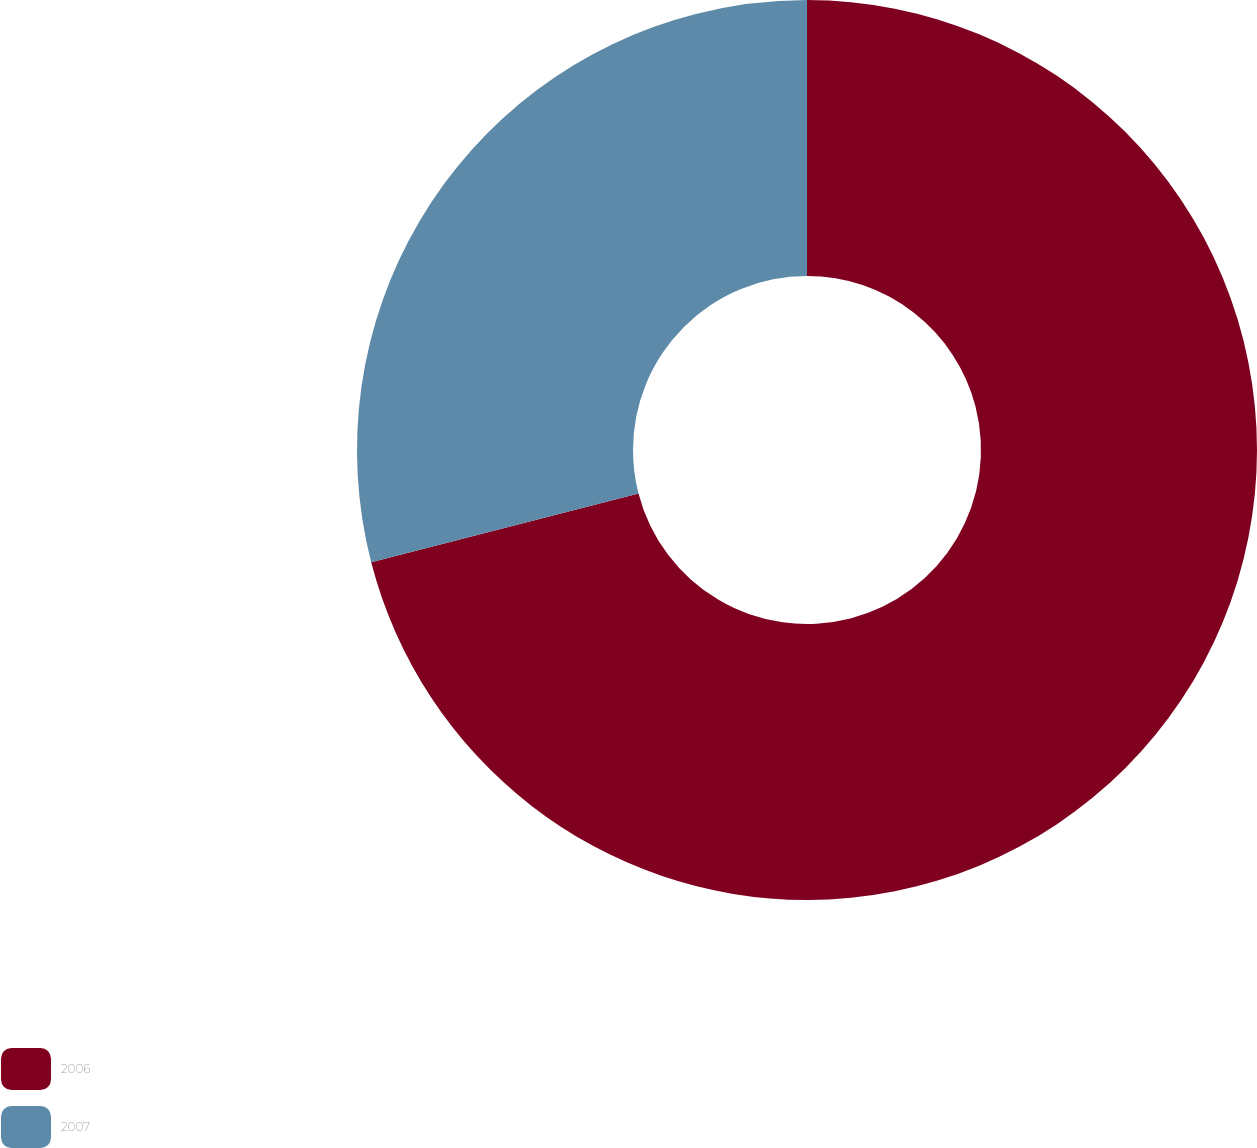Convert chart to OTSL. <chart><loc_0><loc_0><loc_500><loc_500><pie_chart><fcel>2006<fcel>2007<nl><fcel>70.99%<fcel>29.01%<nl></chart> 